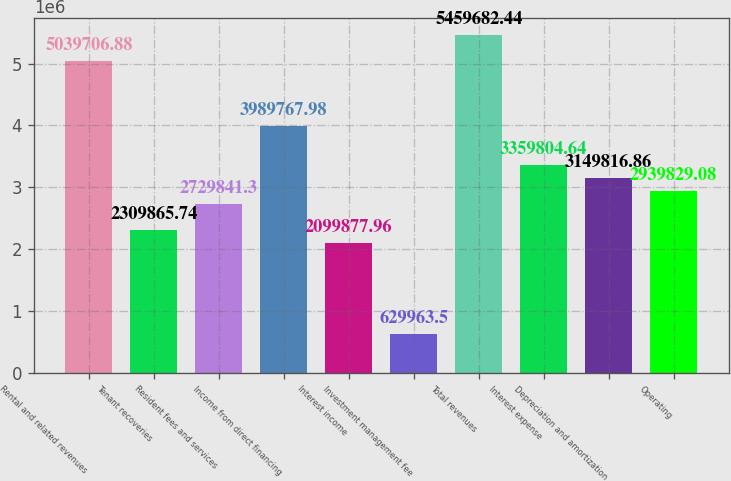Convert chart. <chart><loc_0><loc_0><loc_500><loc_500><bar_chart><fcel>Rental and related revenues<fcel>Tenant recoveries<fcel>Resident fees and services<fcel>Income from direct financing<fcel>Interest income<fcel>Investment management fee<fcel>Total revenues<fcel>Interest expense<fcel>Depreciation and amortization<fcel>Operating<nl><fcel>5.03971e+06<fcel>2.30987e+06<fcel>2.72984e+06<fcel>3.98977e+06<fcel>2.09988e+06<fcel>629964<fcel>5.45968e+06<fcel>3.3598e+06<fcel>3.14982e+06<fcel>2.93983e+06<nl></chart> 